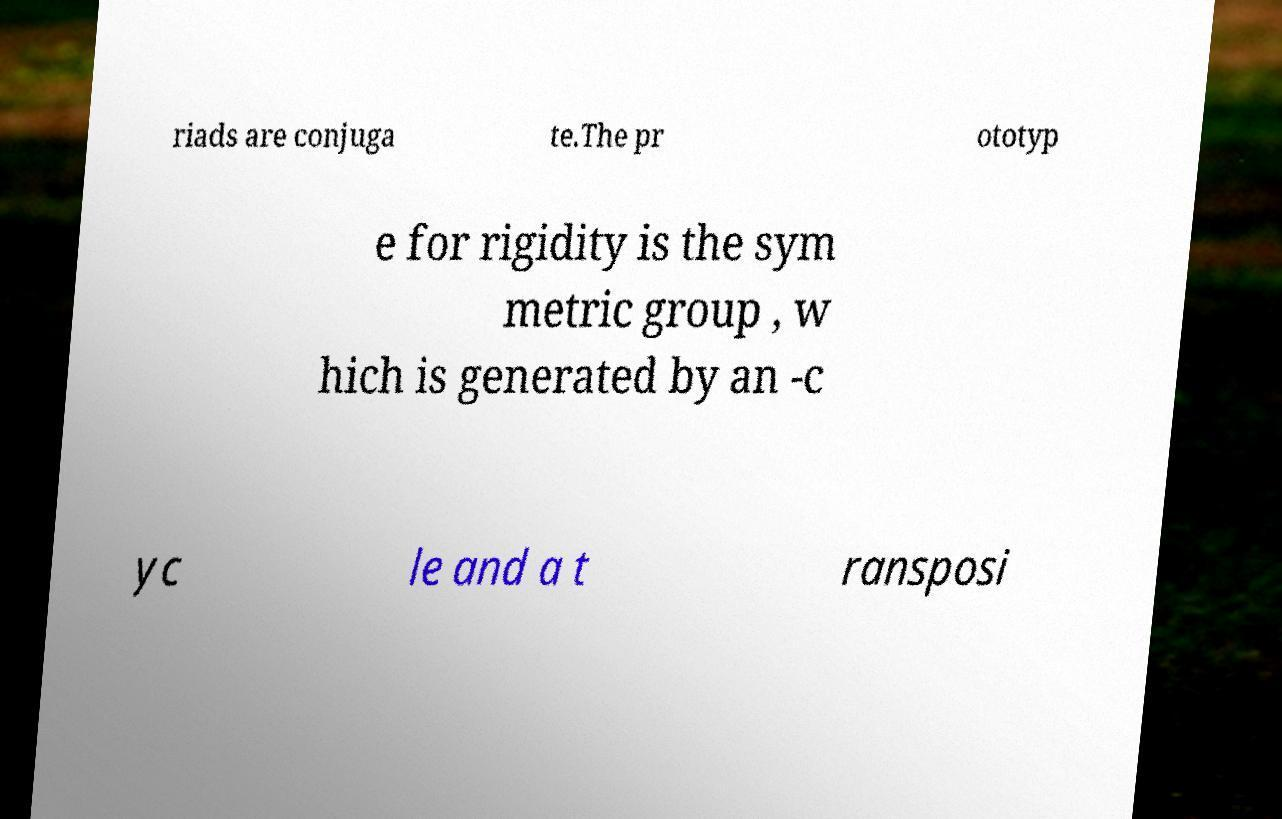Can you read and provide the text displayed in the image?This photo seems to have some interesting text. Can you extract and type it out for me? riads are conjuga te.The pr ototyp e for rigidity is the sym metric group , w hich is generated by an -c yc le and a t ransposi 